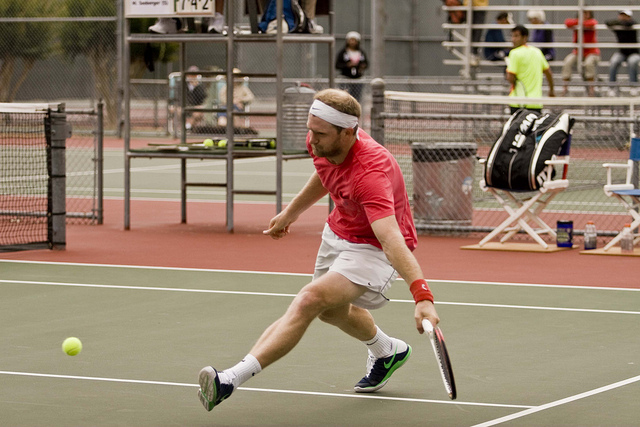Identify and read out the text in this image. 142 